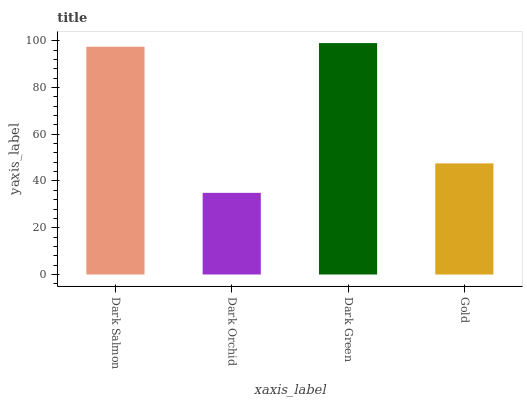Is Dark Green the minimum?
Answer yes or no. No. Is Dark Orchid the maximum?
Answer yes or no. No. Is Dark Green greater than Dark Orchid?
Answer yes or no. Yes. Is Dark Orchid less than Dark Green?
Answer yes or no. Yes. Is Dark Orchid greater than Dark Green?
Answer yes or no. No. Is Dark Green less than Dark Orchid?
Answer yes or no. No. Is Dark Salmon the high median?
Answer yes or no. Yes. Is Gold the low median?
Answer yes or no. Yes. Is Dark Orchid the high median?
Answer yes or no. No. Is Dark Salmon the low median?
Answer yes or no. No. 